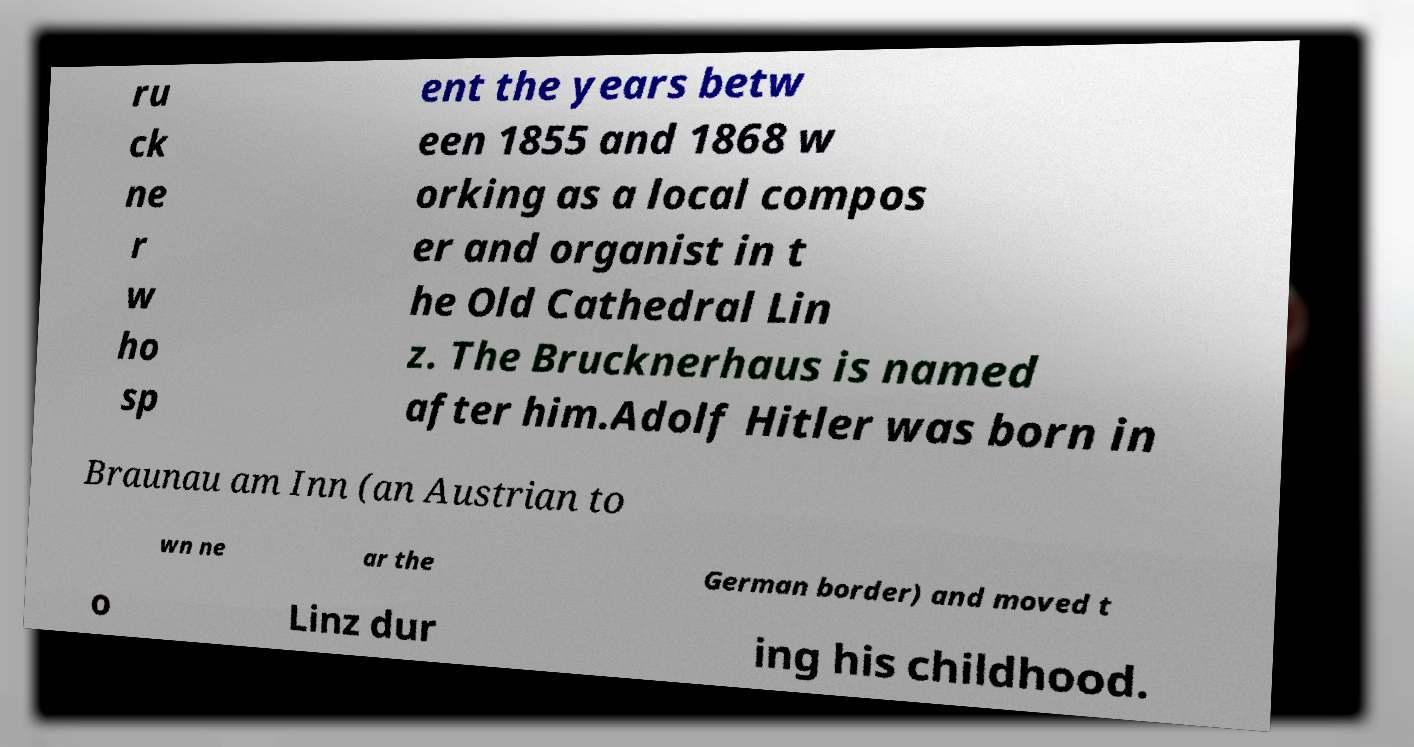Can you accurately transcribe the text from the provided image for me? ru ck ne r w ho sp ent the years betw een 1855 and 1868 w orking as a local compos er and organist in t he Old Cathedral Lin z. The Brucknerhaus is named after him.Adolf Hitler was born in Braunau am Inn (an Austrian to wn ne ar the German border) and moved t o Linz dur ing his childhood. 